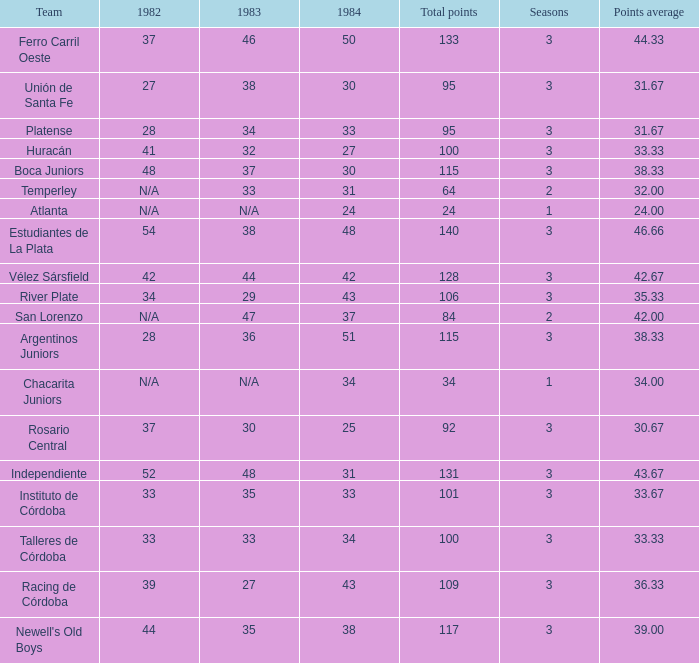What is the points total for the team with points average more than 34, 1984 score more than 37 and N/A in 1982? 0.0. 